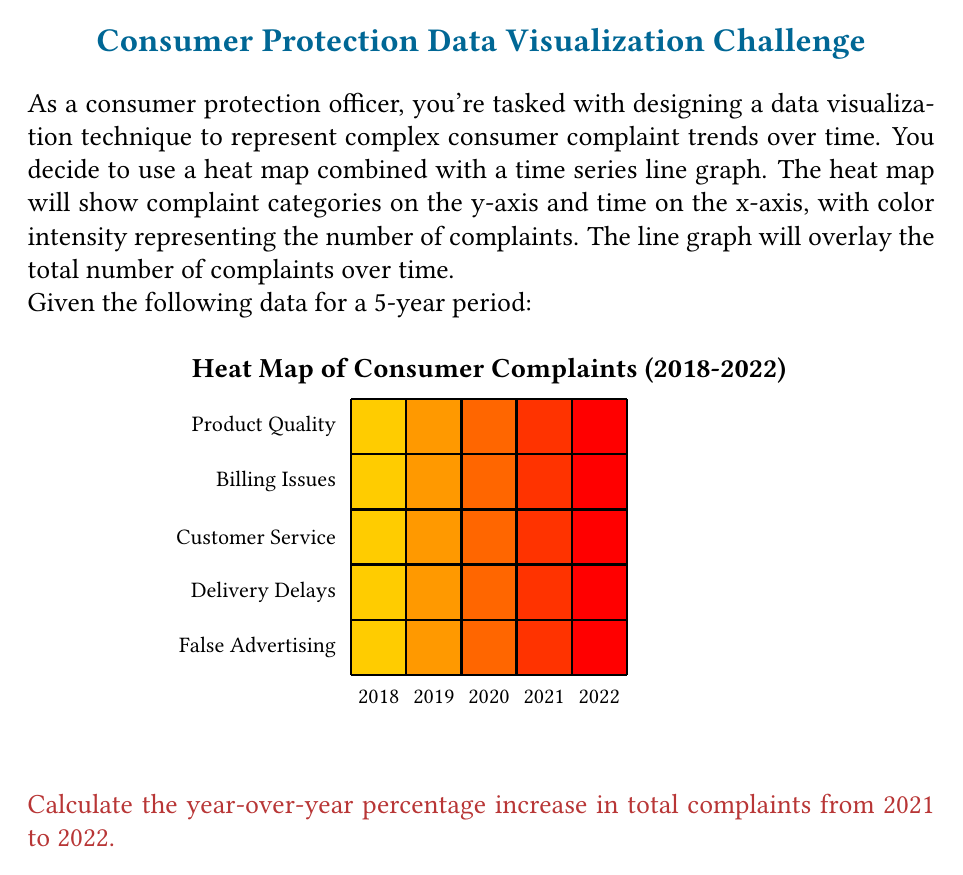Give your solution to this math problem. To solve this problem, we'll follow these steps:

1) Calculate the total complaints for 2021 and 2022.
2) Calculate the year-over-year percentage increase.

Step 1: Calculate total complaints

For 2021:
$$ \text{Total}_{2021} = 150 + 180 + 130 + 80 + 70 = 610 $$

For 2022:
$$ \text{Total}_{2022} = 200 + 210 + 150 + 100 + 90 = 750 $$

Step 2: Calculate the year-over-year percentage increase

The formula for percentage increase is:

$$ \text{Percentage Increase} = \frac{\text{New Value} - \text{Original Value}}{\text{Original Value}} \times 100\% $$

Plugging in our values:

$$ \text{Percentage Increase} = \frac{750 - 610}{610} \times 100\% $$

$$ = \frac{140}{610} \times 100\% $$

$$ \approx 0.2295 \times 100\% $$

$$ \approx 22.95\% $$

Therefore, the year-over-year percentage increase in total complaints from 2021 to 2022 is approximately 22.95%.
Answer: 22.95% 